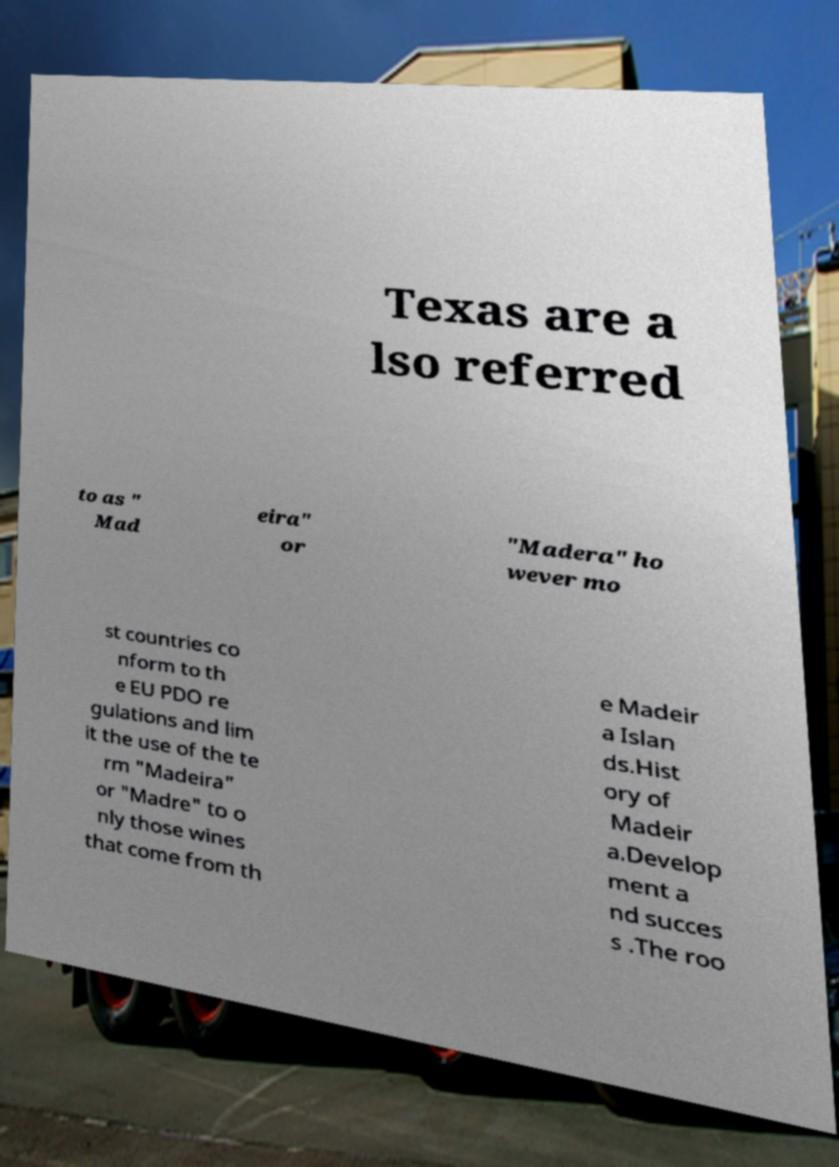Can you accurately transcribe the text from the provided image for me? Texas are a lso referred to as " Mad eira" or "Madera" ho wever mo st countries co nform to th e EU PDO re gulations and lim it the use of the te rm "Madeira" or "Madre" to o nly those wines that come from th e Madeir a Islan ds.Hist ory of Madeir a.Develop ment a nd succes s .The roo 